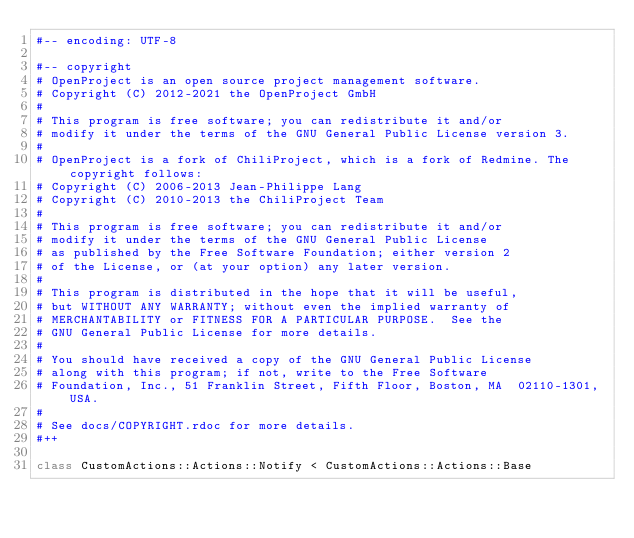Convert code to text. <code><loc_0><loc_0><loc_500><loc_500><_Ruby_>#-- encoding: UTF-8

#-- copyright
# OpenProject is an open source project management software.
# Copyright (C) 2012-2021 the OpenProject GmbH
#
# This program is free software; you can redistribute it and/or
# modify it under the terms of the GNU General Public License version 3.
#
# OpenProject is a fork of ChiliProject, which is a fork of Redmine. The copyright follows:
# Copyright (C) 2006-2013 Jean-Philippe Lang
# Copyright (C) 2010-2013 the ChiliProject Team
#
# This program is free software; you can redistribute it and/or
# modify it under the terms of the GNU General Public License
# as published by the Free Software Foundation; either version 2
# of the License, or (at your option) any later version.
#
# This program is distributed in the hope that it will be useful,
# but WITHOUT ANY WARRANTY; without even the implied warranty of
# MERCHANTABILITY or FITNESS FOR A PARTICULAR PURPOSE.  See the
# GNU General Public License for more details.
#
# You should have received a copy of the GNU General Public License
# along with this program; if not, write to the Free Software
# Foundation, Inc., 51 Franklin Street, Fifth Floor, Boston, MA  02110-1301, USA.
#
# See docs/COPYRIGHT.rdoc for more details.
#++

class CustomActions::Actions::Notify < CustomActions::Actions::Base</code> 